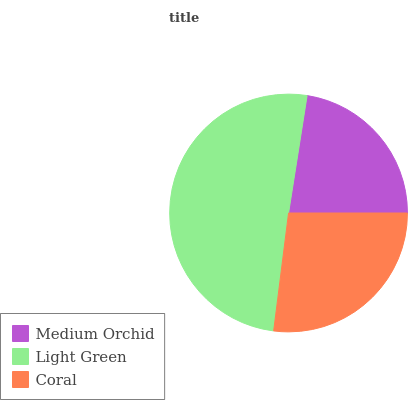Is Medium Orchid the minimum?
Answer yes or no. Yes. Is Light Green the maximum?
Answer yes or no. Yes. Is Coral the minimum?
Answer yes or no. No. Is Coral the maximum?
Answer yes or no. No. Is Light Green greater than Coral?
Answer yes or no. Yes. Is Coral less than Light Green?
Answer yes or no. Yes. Is Coral greater than Light Green?
Answer yes or no. No. Is Light Green less than Coral?
Answer yes or no. No. Is Coral the high median?
Answer yes or no. Yes. Is Coral the low median?
Answer yes or no. Yes. Is Medium Orchid the high median?
Answer yes or no. No. Is Medium Orchid the low median?
Answer yes or no. No. 